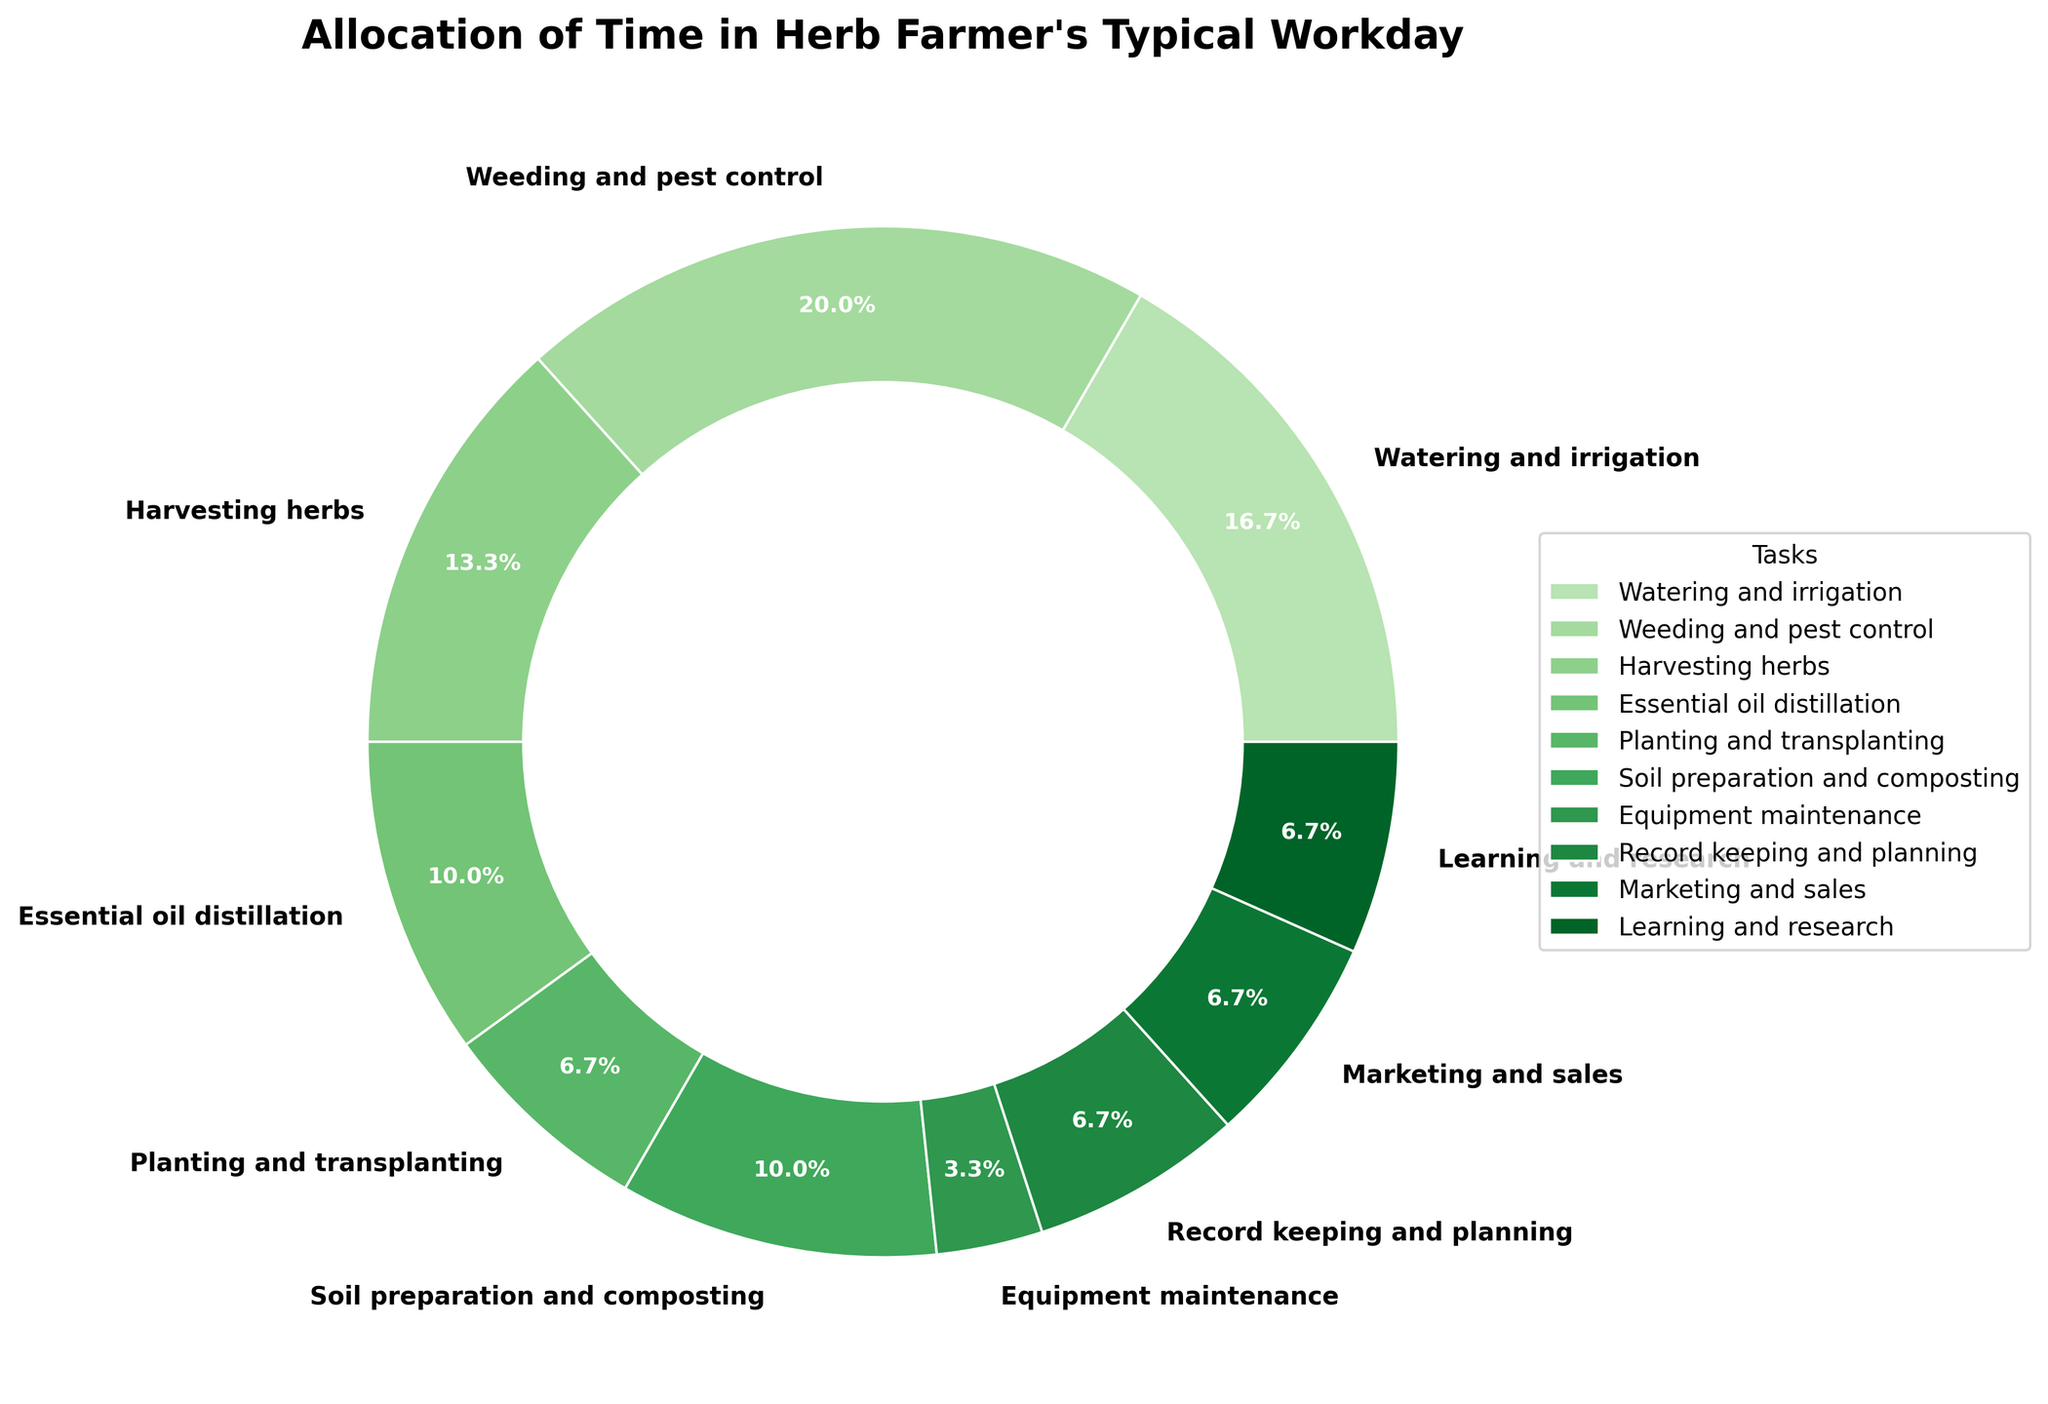Which task takes up the largest proportion of the herb farmer's workday? By looking at the pie chart, identify the slice that takes up the most space. This can be seen by comparing the sizes of the slices directly. The largest slice represents Weeding and pest control.
Answer: Weeding and pest control Which two tasks combined account for more hours than Essential oil distillation? We can see that Weeding and pest control takes up 3 hours, and Harvesting herbs takes up 2 hours. Adding these two gives 5 hours, which is more than the 1.5 hours for Essential oil distillation.
Answer: Weeding and pest control, and Harvesting herbs How does the time spent on Watering and irrigation compare to the time spent on Marketing and sales? Check the portion of the pie chart allocated to both tasks. Watering and irrigation takes up 2.5 hours, which is larger than the 1 hour for Marketing and sales.
Answer: More time spent on Watering and irrigation What is the total time spent on Soil preparation and composting and Essential oil distillation? Add the hours for these tasks directly from the chart. Soil preparation and composting is 1.5 hours and Essential oil distillation is 1.5 hours. The total is 1.5 + 1.5 = 3 hours.
Answer: 3 hours What percentage of the farmer's workday is spent on Record keeping and planning combined with Learning and research? Add the hours of both segments and then convert into a percentage. Record keeping and planning is 1 hour and Learning and research is 1 hour. Total hours = 1 + 1 = 2. Convert to percentage: 2/15 * 100 = 13.3%.
Answer: 13.3% Which task takes up half the time spent on Weeding and pest control? Note Weeding and pest control takes 3 hours. Half of this is 1.5 hours. By checking the pie chart, Essential oil distillation, and Soil preparation and composting each take 1.5 hours.
Answer: Essential oil distillation, and Soil preparation and composting Are there any tasks that take up 10% or less of the herb farmer's workday? Check each segment in the pie chart to see if any are 1.5 hours or less, as 10% of 15 hours is 1.5. Equipment maintenance takes 0.5 hours, which is less than 10%. Marketing and sales, Record keeping and planning, and Learning and research take exactly 1 hour each, which is 6.7%.
Answer: Equipment maintenance, Marketing and sales, Record keeping and planning, and Learning and research 